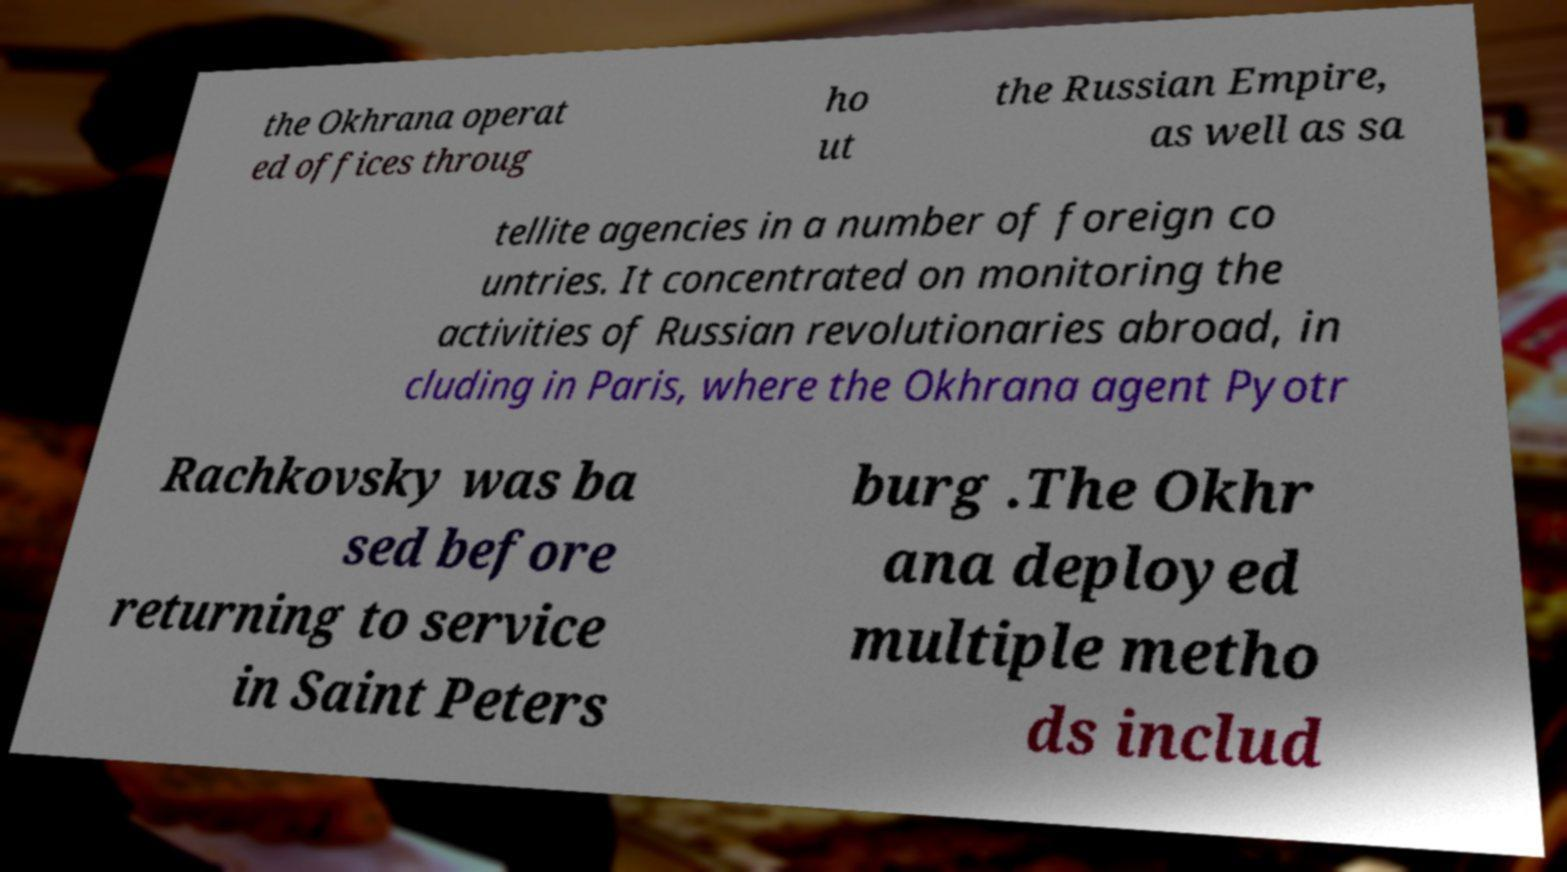Please identify and transcribe the text found in this image. the Okhrana operat ed offices throug ho ut the Russian Empire, as well as sa tellite agencies in a number of foreign co untries. It concentrated on monitoring the activities of Russian revolutionaries abroad, in cluding in Paris, where the Okhrana agent Pyotr Rachkovsky was ba sed before returning to service in Saint Peters burg .The Okhr ana deployed multiple metho ds includ 